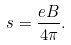<formula> <loc_0><loc_0><loc_500><loc_500>s = \frac { e B } { 4 \pi } .</formula> 